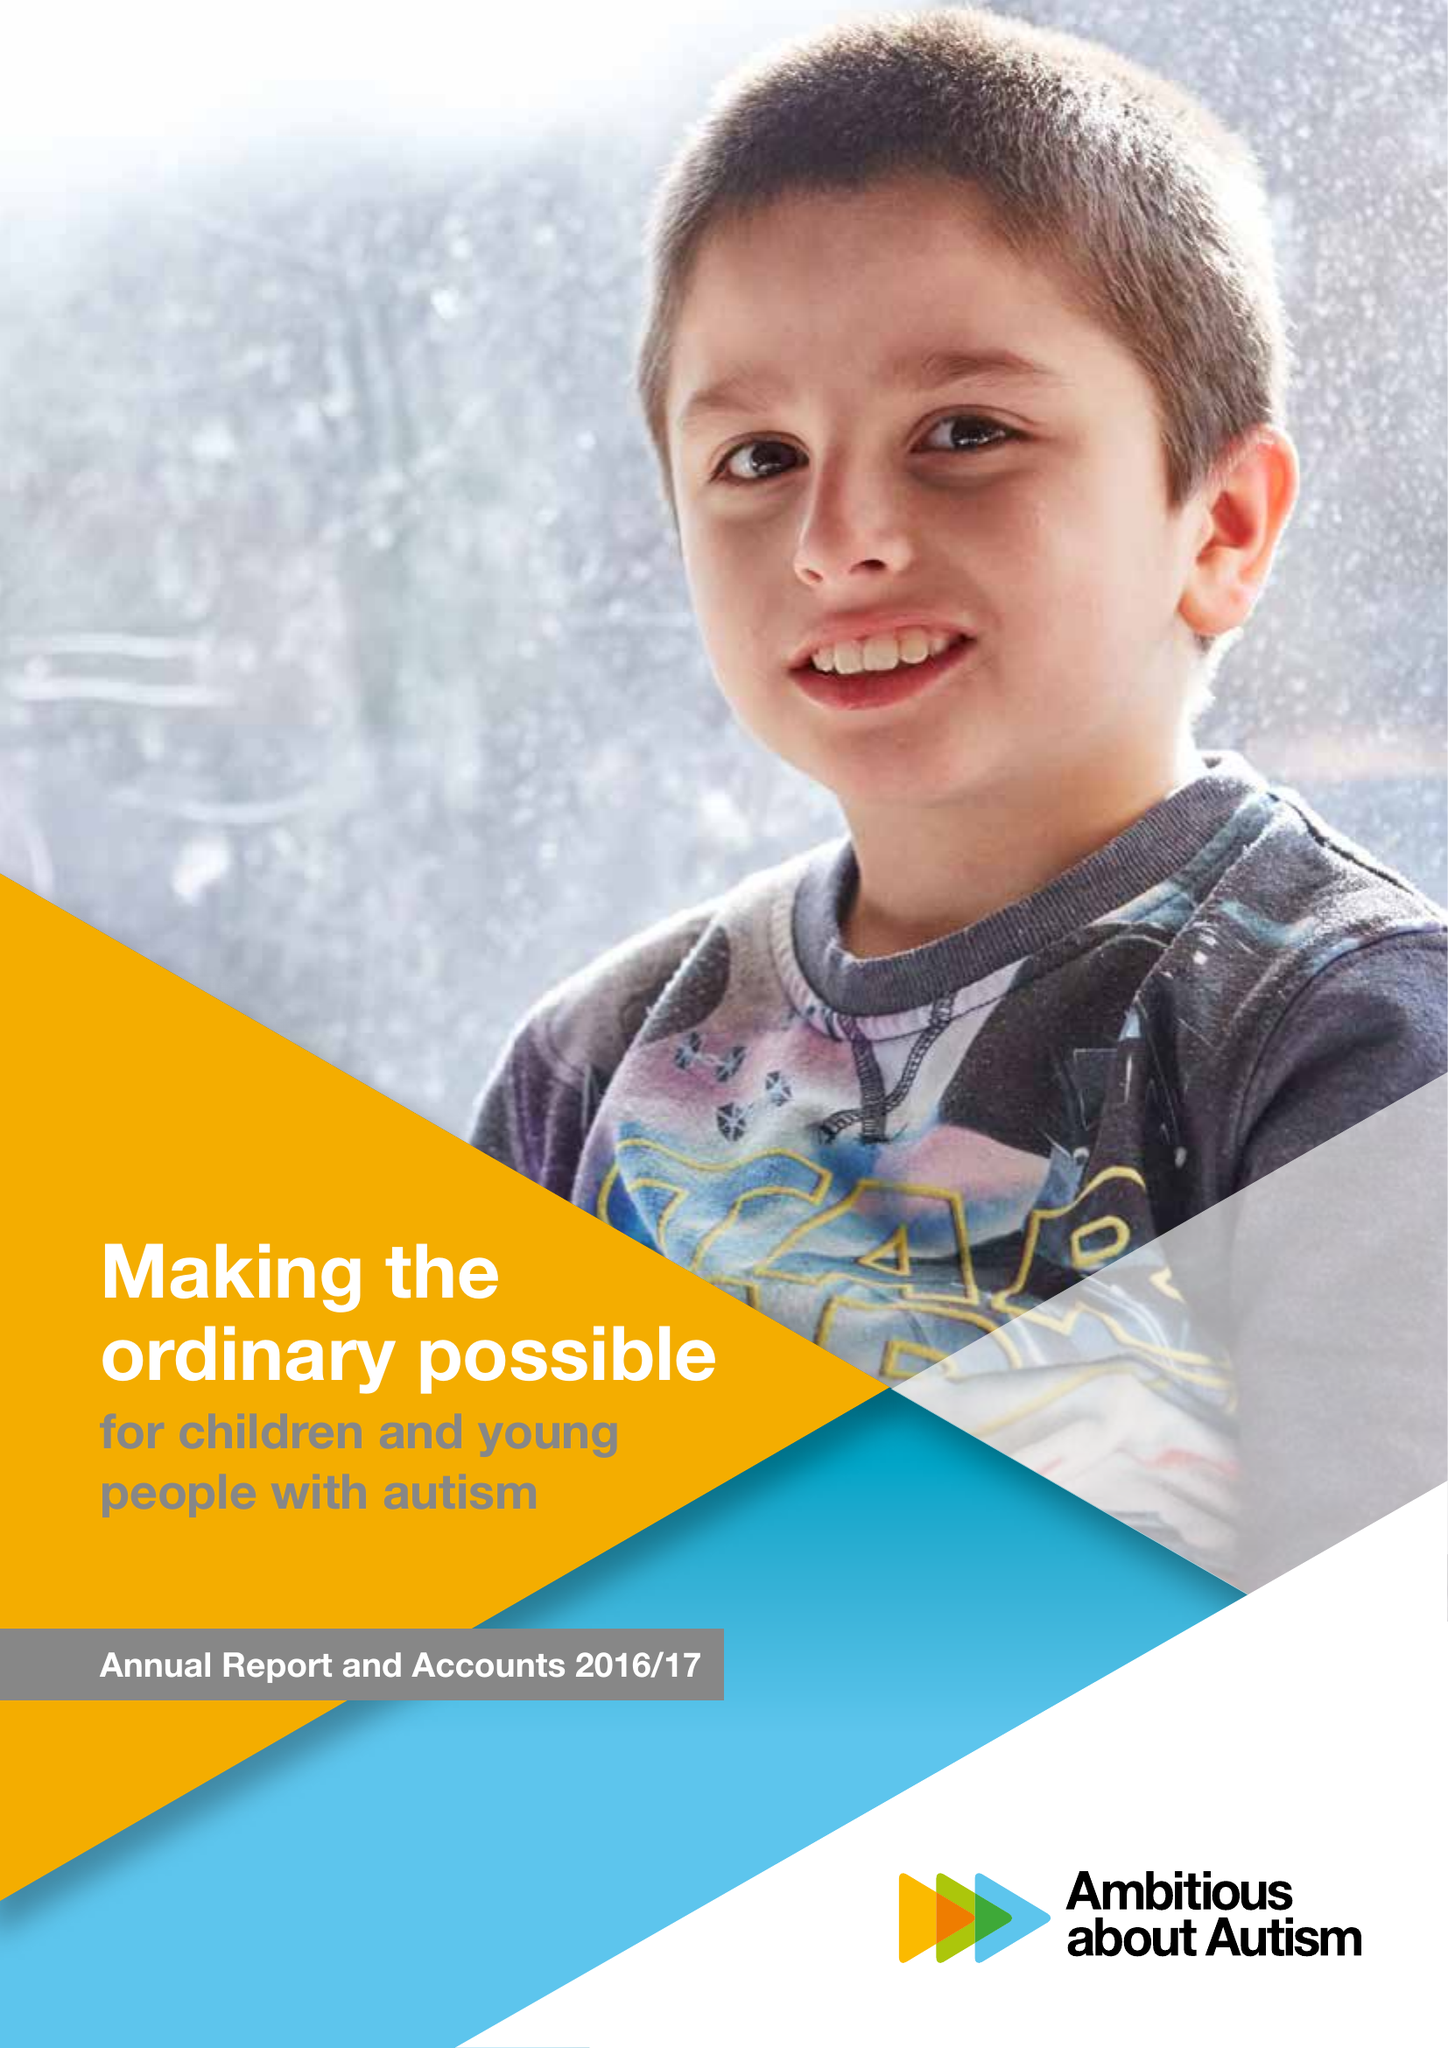What is the value for the charity_name?
Answer the question using a single word or phrase. Ambitious About Autism 